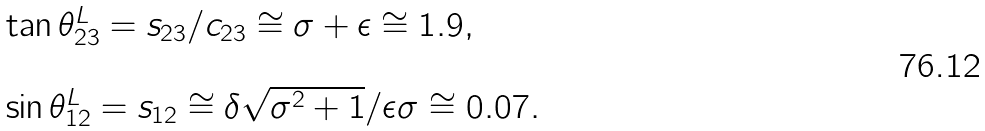Convert formula to latex. <formula><loc_0><loc_0><loc_500><loc_500>\begin{array} { l } \tan \theta ^ { L } _ { 2 3 } = s _ { 2 3 } / c _ { 2 3 } \cong \sigma + \epsilon \cong 1 . 9 , \\ \\ \sin \theta ^ { L } _ { 1 2 } = s _ { 1 2 } \cong \delta \sqrt { \sigma ^ { 2 } + 1 } / \epsilon \sigma \cong 0 . 0 7 . \end{array}</formula> 